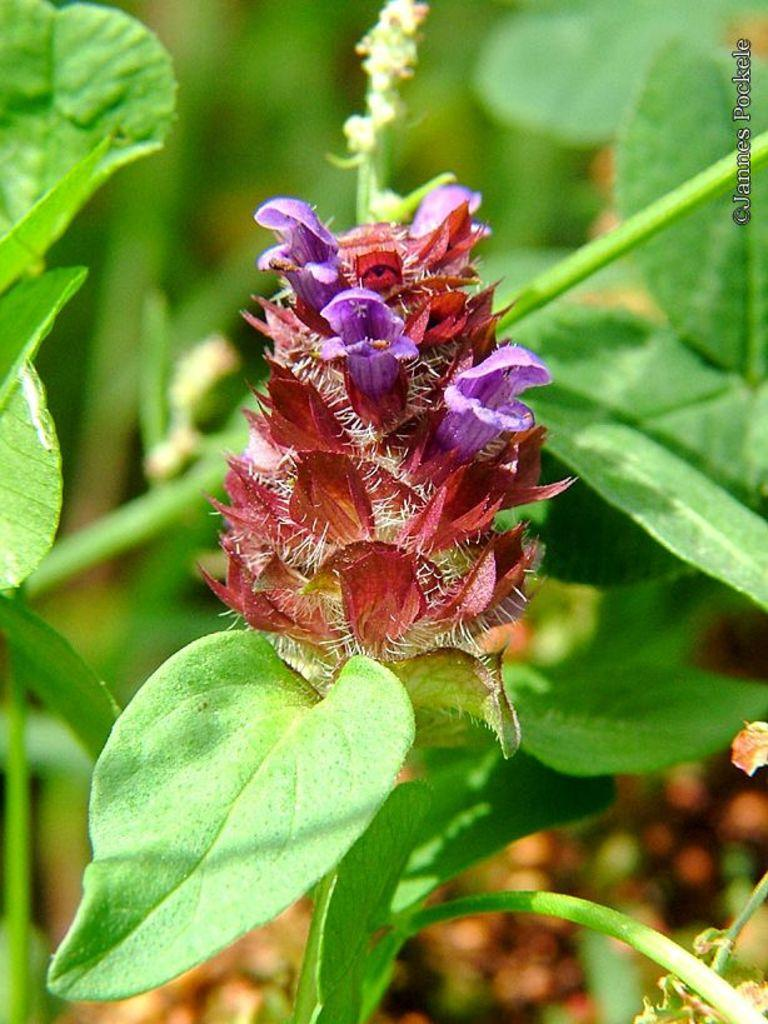What type of plant is in the image? There is a flower plant in the image. What colors are the flowers on the plant? The flowers on the plant are purple and red. Where is the flower plant located in the image? The flower plant is in the front of the image. What else can be seen on the plant besides the flowers? There are green leaves visible in the image. How many hands are visible holding the flower plant in the image? There are no hands visible holding the flower plant in the image; it is standing on its own. 